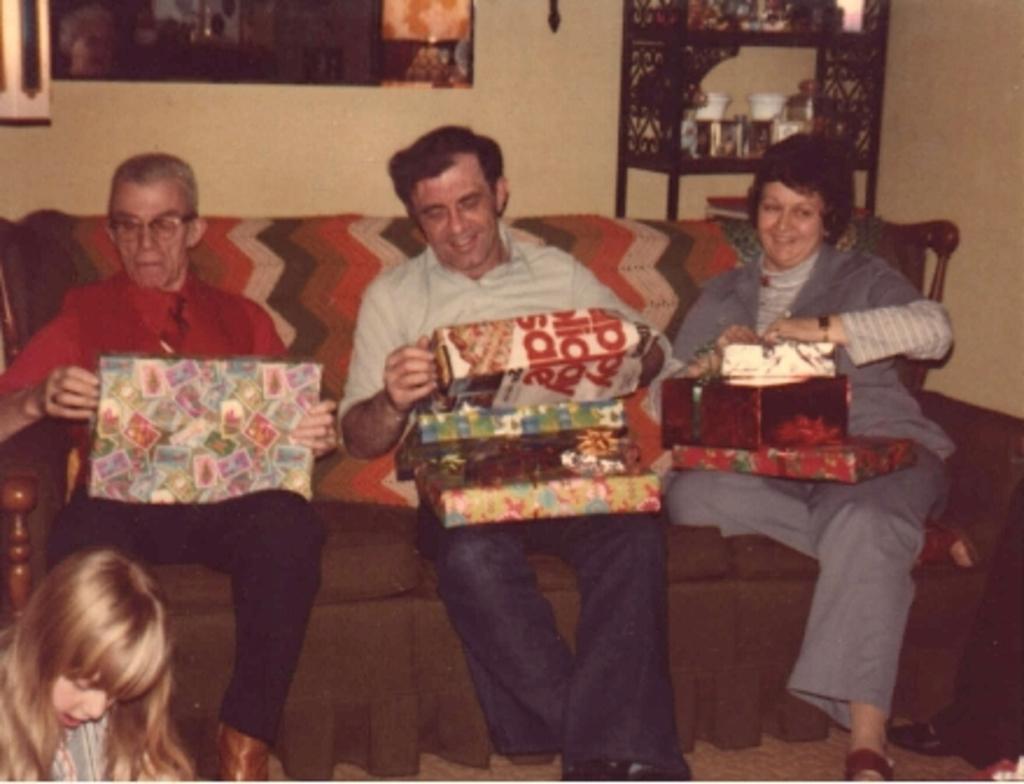Please provide a concise description of this image. In this image there are three persons sitting on the sofa by holding the gift boxes. On the left side bottom there is a girl. On the right side top there is a cupboard in which there are glasses and bowls. 